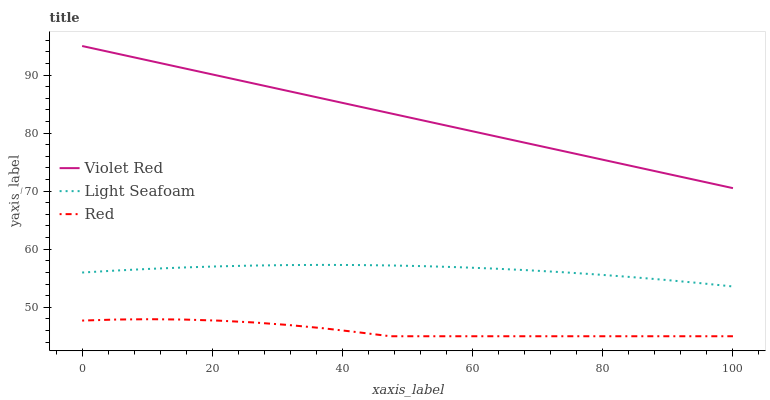Does Red have the minimum area under the curve?
Answer yes or no. Yes. Does Violet Red have the maximum area under the curve?
Answer yes or no. Yes. Does Light Seafoam have the minimum area under the curve?
Answer yes or no. No. Does Light Seafoam have the maximum area under the curve?
Answer yes or no. No. Is Violet Red the smoothest?
Answer yes or no. Yes. Is Red the roughest?
Answer yes or no. Yes. Is Light Seafoam the smoothest?
Answer yes or no. No. Is Light Seafoam the roughest?
Answer yes or no. No. Does Red have the lowest value?
Answer yes or no. Yes. Does Light Seafoam have the lowest value?
Answer yes or no. No. Does Violet Red have the highest value?
Answer yes or no. Yes. Does Light Seafoam have the highest value?
Answer yes or no. No. Is Light Seafoam less than Violet Red?
Answer yes or no. Yes. Is Light Seafoam greater than Red?
Answer yes or no. Yes. Does Light Seafoam intersect Violet Red?
Answer yes or no. No. 